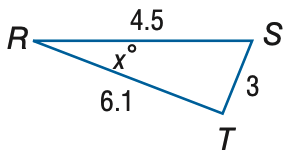Answer the mathemtical geometry problem and directly provide the correct option letter.
Question: Find x. Round to the nearest degree.
Choices: A: 18 B: 23 C: 28 D: 33 C 